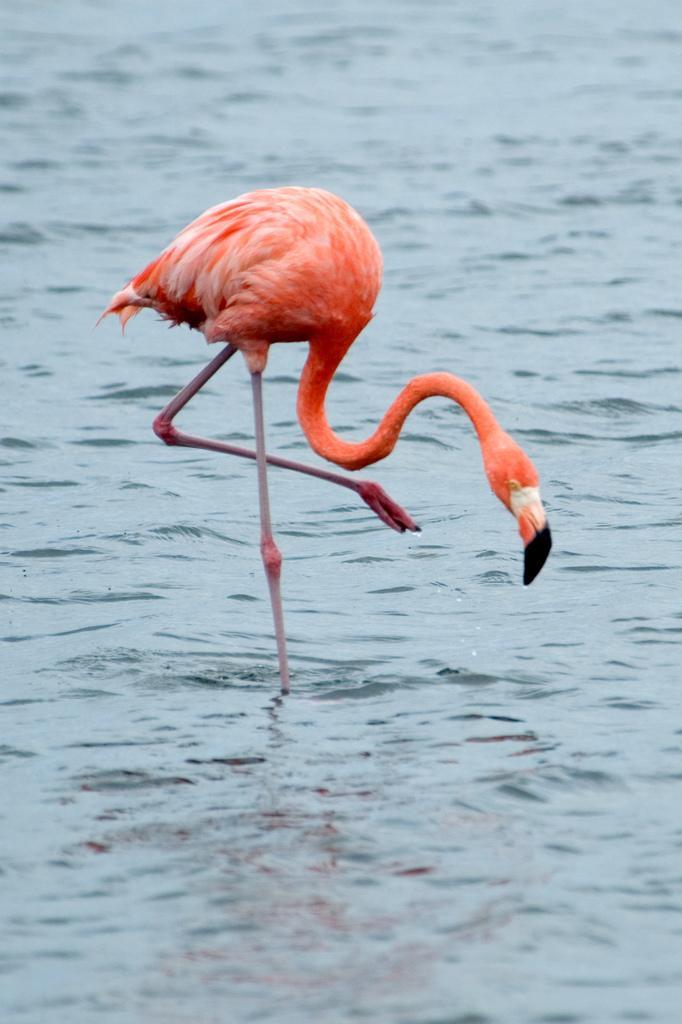Could you give a brief overview of what you see in this image? In this image in the center there is a bird standing in the water. In the background there is water. 